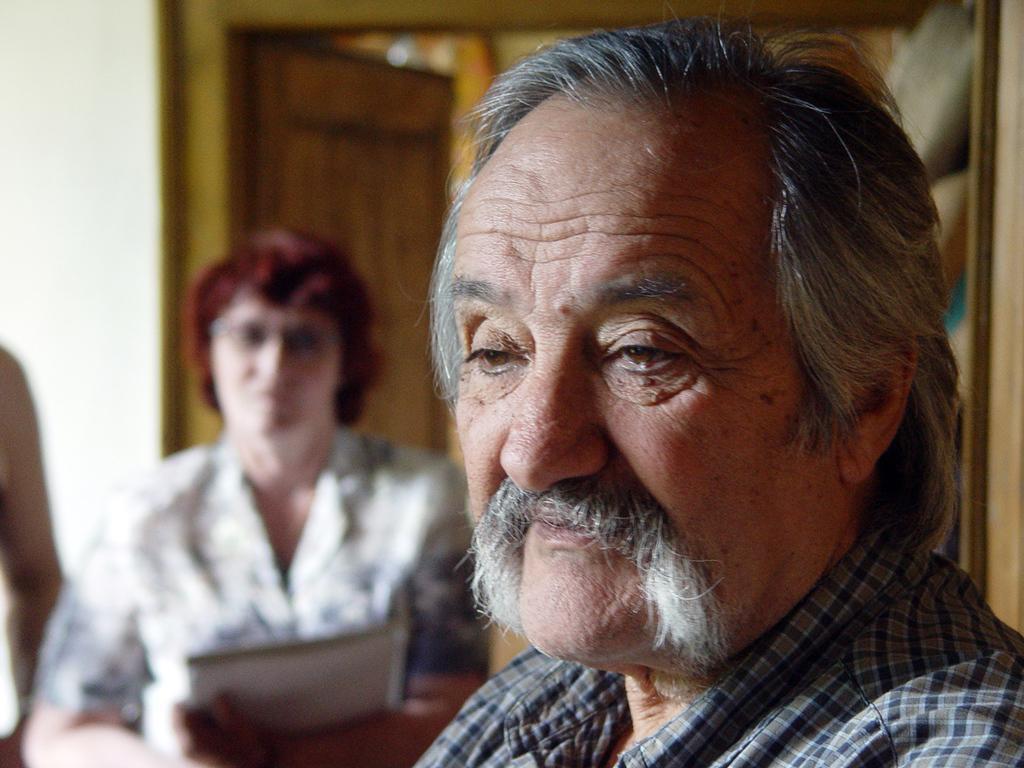Describe this image in one or two sentences. In this image, we can see persons wearing clothes. In the background, image is blurred. 